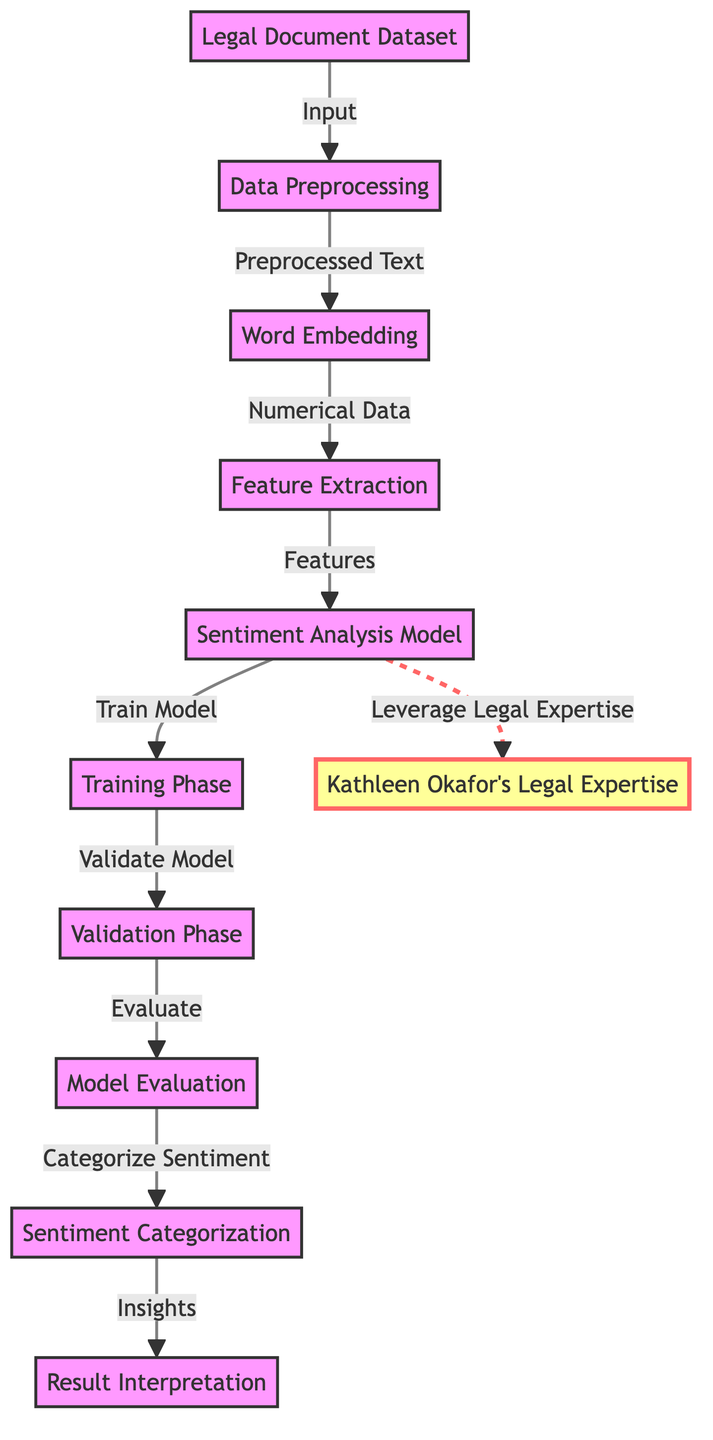What is the starting point of the diagram? The diagram begins with the "Legal Document Dataset" node, which is the first element in the flowchart. This indicates that the process starts with this dataset.
Answer: Legal Document Dataset How many main phases are represented in the diagram? There are four main phases in the diagram: Data Preprocessing, Sentiment Analysis Model, Training Phase, and Validation Phase, which can be counted from the nodes.
Answer: Four What follows after Data Preprocessing in the flowchart? After "Data Preprocessing", the next node in the flowchart is "Word Embedding". This shows the direct flow from preprocessing to embedding.
Answer: Word Embedding What does the "Sentiment Analysis Model" node connect to directly? The "Sentiment Analysis Model" node connects directly to the "Training Phase" node. This shows the flow of operations from the model to the training of that model.
Answer: Training Phase Which node represents the final output of the sentiment analysis process? The final output of the sentiment analysis process is represented by the "Result Interpretation" node, as it highlights the insights gained from categorizing the sentiment.
Answer: Result Interpretation What relationship exists between the "Sentiment Analysis Model" and "Kathleen Okafor's Legal Expertise"? The relationship is a dashed line indicating that the "Sentiment Analysis Model" leverages "Kathleen Okafor's Legal Expertise". This suggests that her expertise is not directly part of the model but enhances its outcomes.
Answer: Leverage Legal Expertise What kind of data is produced by the "Word Embedding" node? The "Word Embedding" node produces "Numerical Data", referring to the transformation of text into a numerical format for further analysis.
Answer: Numerical Data In which phase is the model validated? The model is validated during the "Validation Phase", which directly follows the "Training Phase". This indicates a sequential approach where validation occurs after training.
Answer: Validation Phase What are the insights derived from the emotion categorization phase? The insights are derived from the "Result Interpretation" node, which signifies the culmination of the sentiment analysis process by interpreting the categorized results.
Answer: Insights 